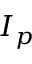<formula> <loc_0><loc_0><loc_500><loc_500>I _ { p }</formula> 